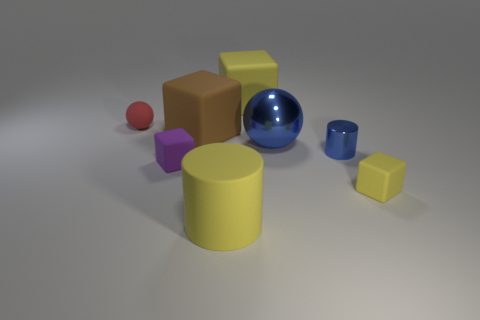Are any small yellow matte objects visible?
Make the answer very short. Yes. There is a yellow matte object on the right side of the yellow matte cube that is behind the ball that is left of the large cylinder; what is its shape?
Provide a succinct answer. Cube. What number of large brown matte cubes are right of the yellow cylinder?
Keep it short and to the point. 0. Is the material of the blue thing that is behind the tiny blue cylinder the same as the tiny purple thing?
Provide a short and direct response. No. What number of other things are the same shape as the small red rubber object?
Give a very brief answer. 1. How many small purple things are behind the large yellow object behind the blue metallic object that is in front of the large blue metal sphere?
Make the answer very short. 0. There is a small rubber cube to the right of the yellow cylinder; what color is it?
Offer a very short reply. Yellow. Does the object that is behind the matte ball have the same color as the small ball?
Your response must be concise. No. What is the size of the purple matte object that is the same shape as the large brown rubber thing?
Give a very brief answer. Small. Is there anything else that is the same size as the blue sphere?
Give a very brief answer. Yes. 